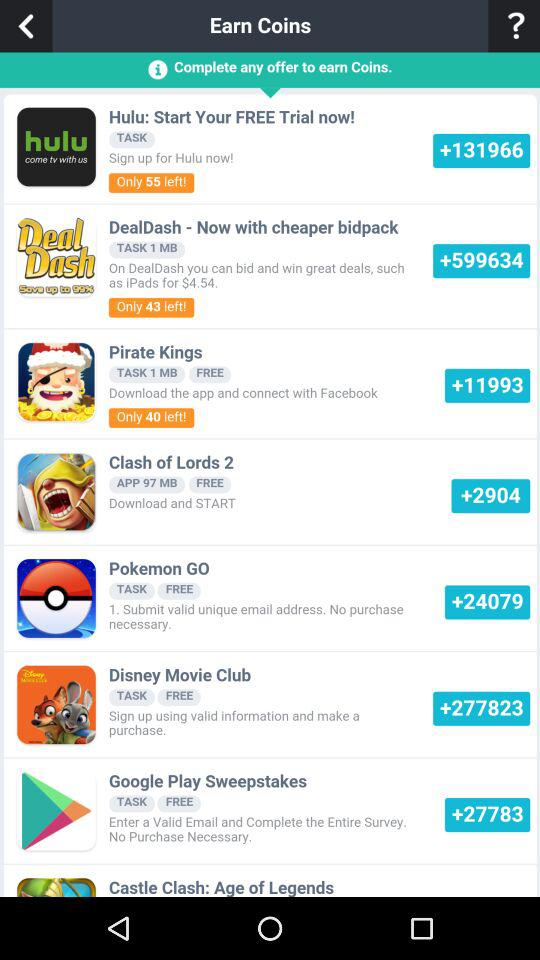How many free trials are left on "Hulu"? There are only 55 free trails left. 